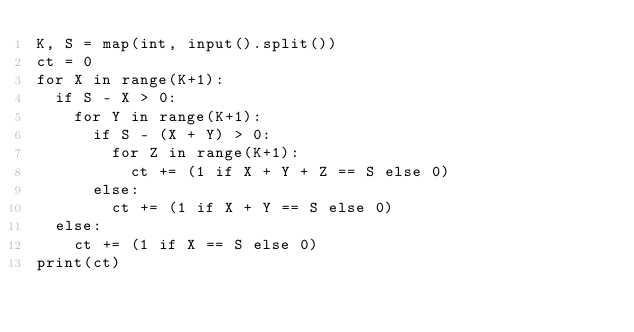Convert code to text. <code><loc_0><loc_0><loc_500><loc_500><_Python_>K, S = map(int, input().split())
ct = 0
for X in range(K+1):
  if S - X > 0:
    for Y in range(K+1):
      if S - (X + Y) > 0:
        for Z in range(K+1):
          ct += (1 if X + Y + Z == S else 0)
      else:
        ct += (1 if X + Y == S else 0)
  else:
    ct += (1 if X == S else 0)
print(ct)</code> 